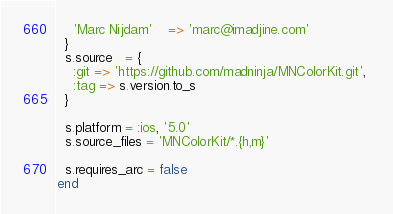Convert code to text. <code><loc_0><loc_0><loc_500><loc_500><_Ruby_>    'Marc Nijdam'    => 'marc@imadjine.com' 
  }
  s.source   = { 
    :git => 'https://github.com/madninja/MNColorKit.git', 
    :tag => s.version.to_s
  }

  s.platform = :ios, '5.0'
  s.source_files = 'MNColorKit/*.{h,m}'

  s.requires_arc = false
end
</code> 